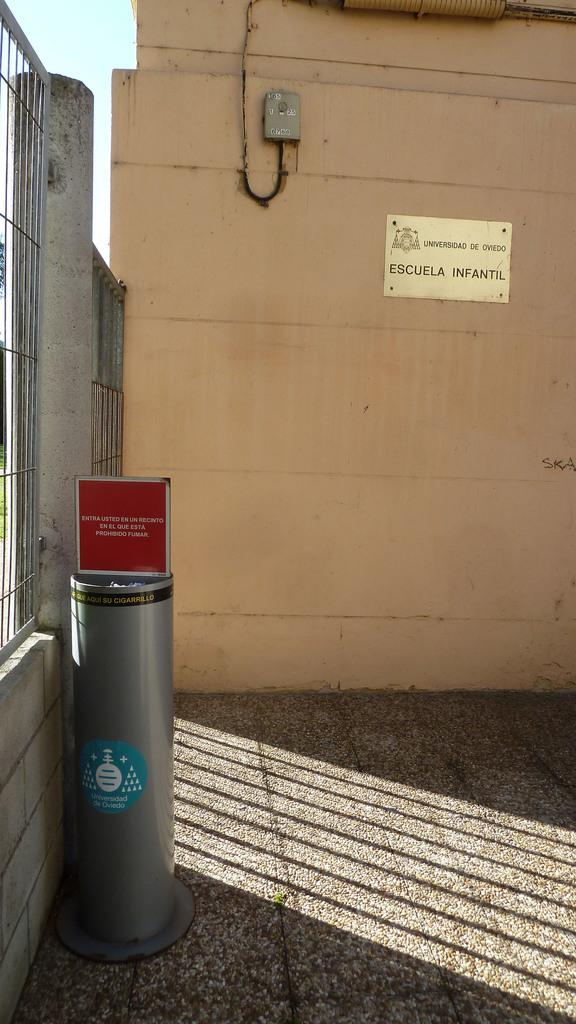<image>
Write a terse but informative summary of the picture. The side of a building with a sign reading Escuela Infantil 